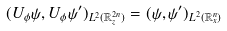Convert formula to latex. <formula><loc_0><loc_0><loc_500><loc_500>( U _ { \phi } \psi , U _ { \phi } \psi ^ { \prime } ) _ { L ^ { 2 } ( \mathbb { R } _ { z } ^ { 2 n } ) } = ( \psi , \psi ^ { \prime } ) _ { L ^ { 2 } ( \mathbb { R } _ { x } ^ { n } ) }</formula> 